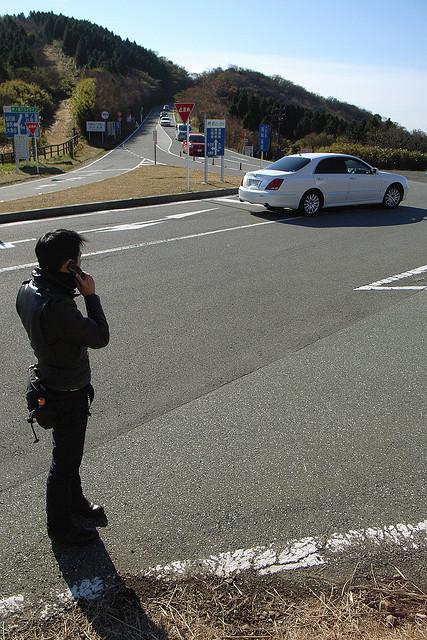Is the man hitchhiking?
Give a very brief answer. No. How many signs are there?
Short answer required. 5. What color is the car?
Short answer required. White. 